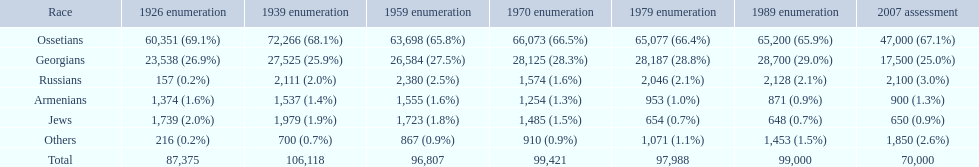Which population had the most people in 1926? Ossetians. 